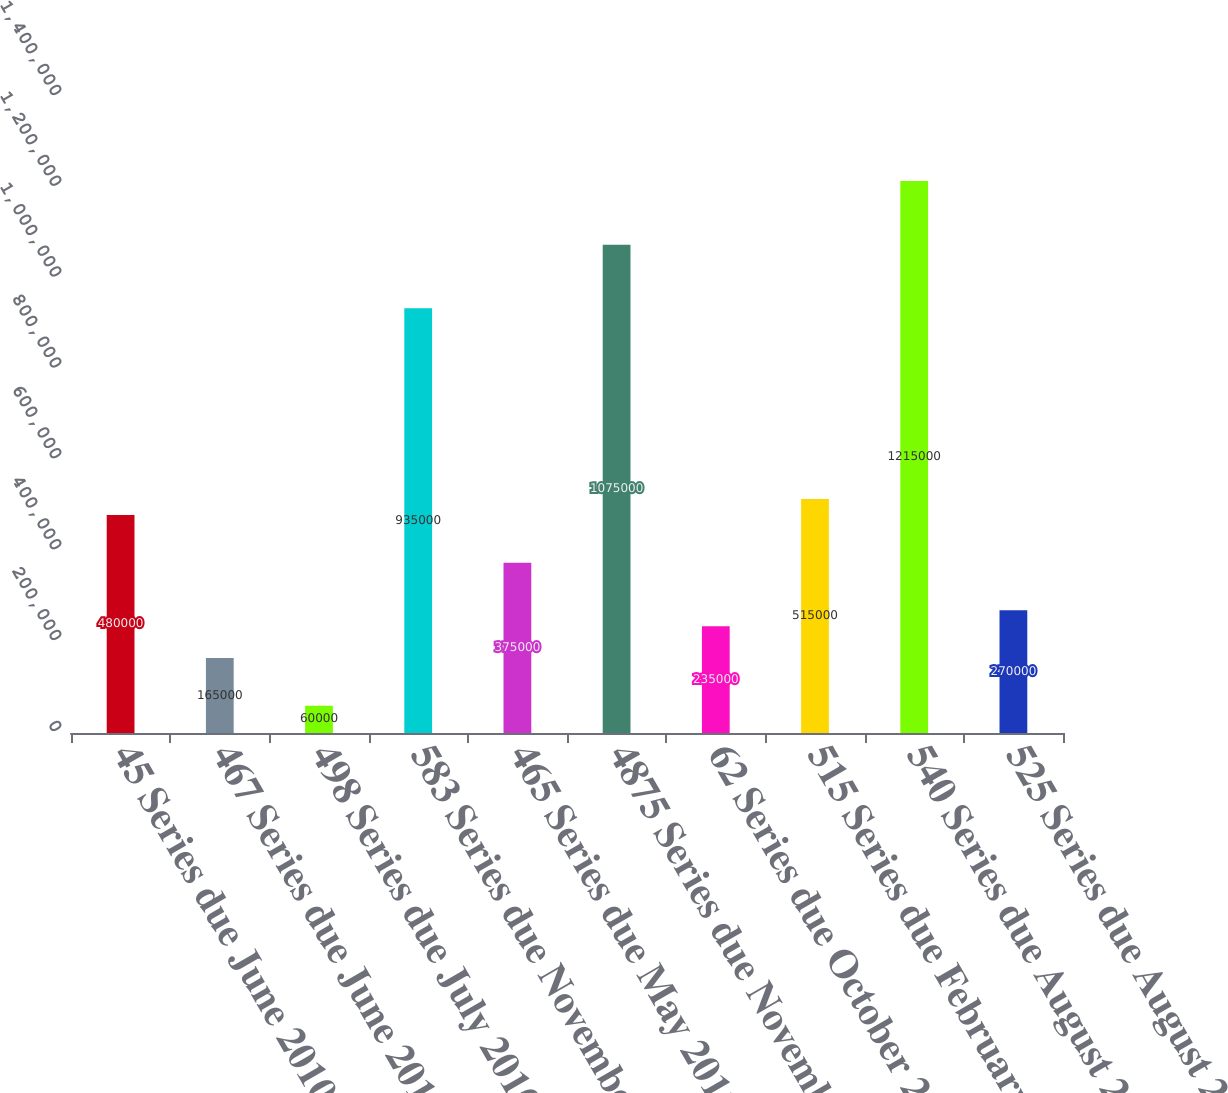<chart> <loc_0><loc_0><loc_500><loc_500><bar_chart><fcel>45 Series due June 2010 -<fcel>467 Series due June 2010 -<fcel>498 Series due July 2010 -<fcel>583 Series due November 2010 -<fcel>465 Series due May 2011 -<fcel>4875 Series due November 2011<fcel>62 Series due October 2012 -<fcel>515 Series due February 2013 -<fcel>540 Series due August 2013 -<fcel>525 Series due August 2013 -<nl><fcel>480000<fcel>165000<fcel>60000<fcel>935000<fcel>375000<fcel>1.075e+06<fcel>235000<fcel>515000<fcel>1.215e+06<fcel>270000<nl></chart> 